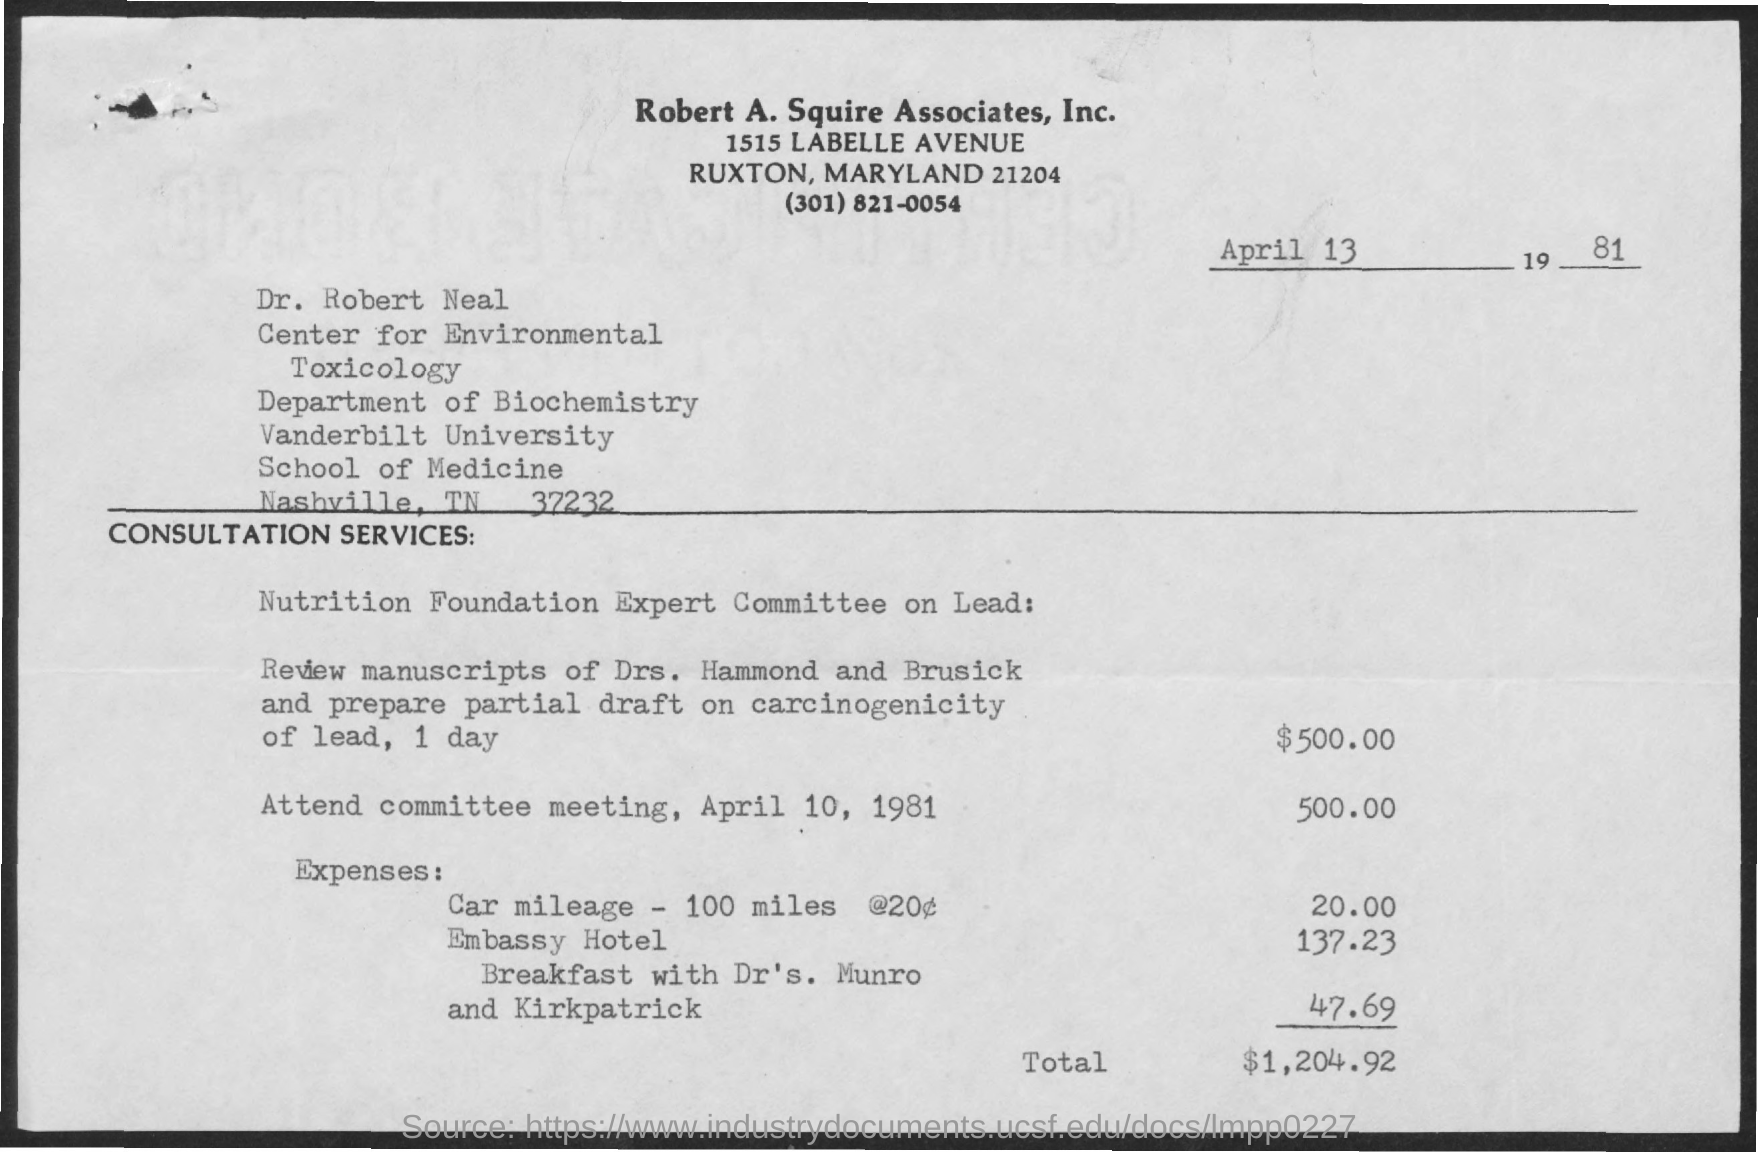Specify some key components in this picture. The amount of expenses for car mileage is 20.00. Dr. Robert Neal is affiliated with Vanderbilt University. Dr. Robert Neal is a member of the Department of Biochemistry. The total amount is $1,204.92. The amount of expenses mentioned for the Embassy Hotel is 137.23... 